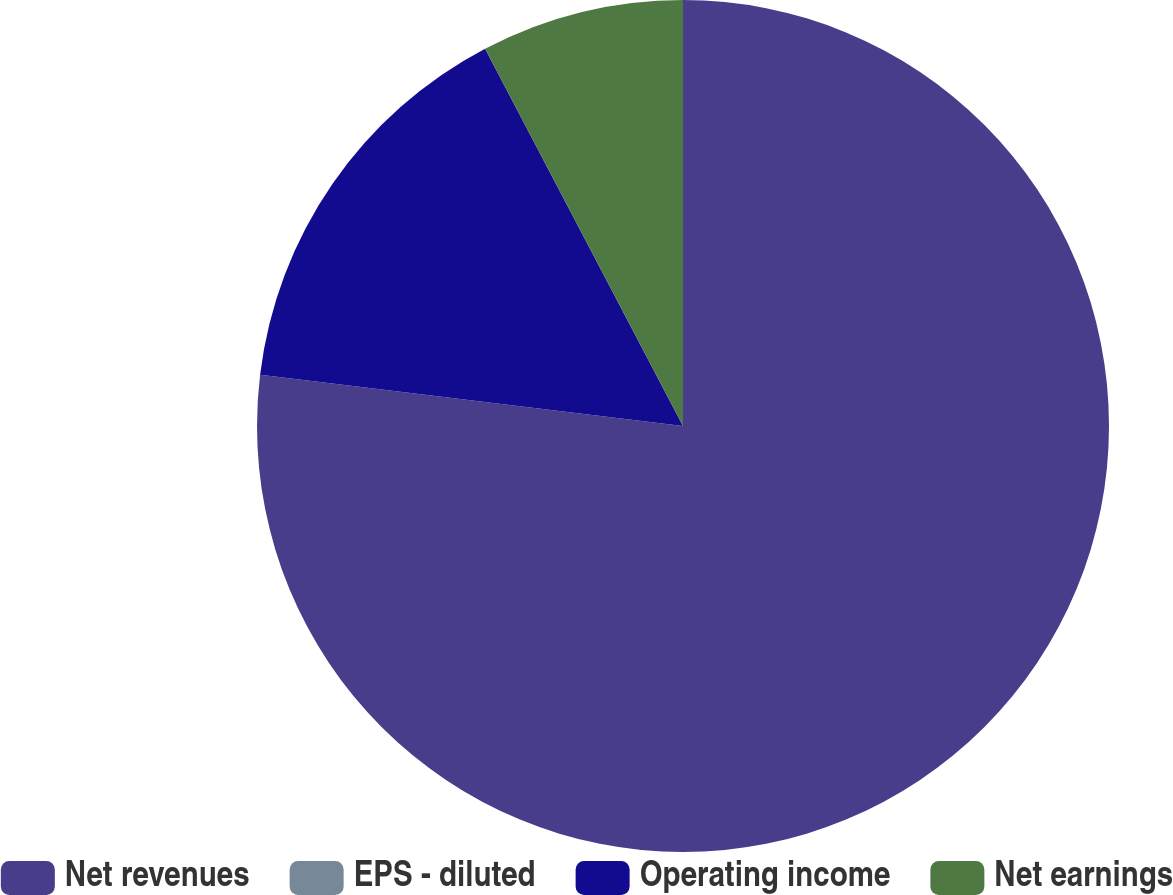<chart> <loc_0><loc_0><loc_500><loc_500><pie_chart><fcel>Net revenues<fcel>EPS - diluted<fcel>Operating income<fcel>Net earnings<nl><fcel>76.92%<fcel>0.0%<fcel>15.39%<fcel>7.69%<nl></chart> 